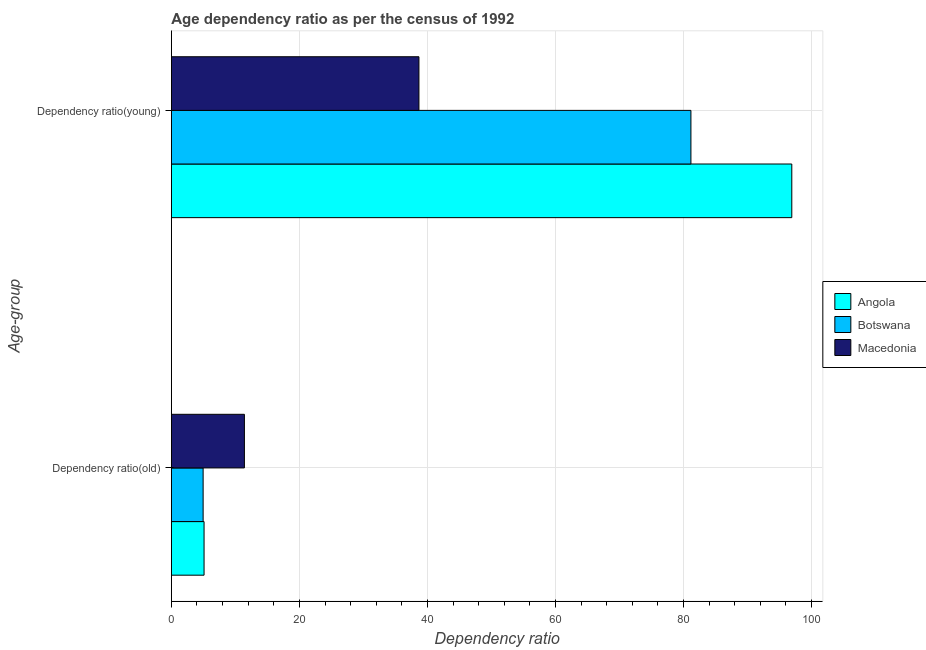How many different coloured bars are there?
Make the answer very short. 3. How many groups of bars are there?
Your answer should be compact. 2. Are the number of bars on each tick of the Y-axis equal?
Your answer should be very brief. Yes. How many bars are there on the 2nd tick from the top?
Give a very brief answer. 3. How many bars are there on the 2nd tick from the bottom?
Your response must be concise. 3. What is the label of the 2nd group of bars from the top?
Your response must be concise. Dependency ratio(old). What is the age dependency ratio(old) in Angola?
Provide a short and direct response. 5.11. Across all countries, what is the maximum age dependency ratio(old)?
Offer a very short reply. 11.41. Across all countries, what is the minimum age dependency ratio(old)?
Ensure brevity in your answer.  4.96. In which country was the age dependency ratio(young) maximum?
Give a very brief answer. Angola. In which country was the age dependency ratio(old) minimum?
Provide a short and direct response. Botswana. What is the total age dependency ratio(young) in the graph?
Your answer should be compact. 216.77. What is the difference between the age dependency ratio(old) in Macedonia and that in Angola?
Keep it short and to the point. 6.3. What is the difference between the age dependency ratio(young) in Macedonia and the age dependency ratio(old) in Botswana?
Your response must be concise. 33.72. What is the average age dependency ratio(old) per country?
Your answer should be very brief. 7.16. What is the difference between the age dependency ratio(young) and age dependency ratio(old) in Angola?
Offer a very short reply. 91.82. In how many countries, is the age dependency ratio(young) greater than 20 ?
Your answer should be compact. 3. What is the ratio of the age dependency ratio(young) in Macedonia to that in Botswana?
Make the answer very short. 0.48. In how many countries, is the age dependency ratio(young) greater than the average age dependency ratio(young) taken over all countries?
Your response must be concise. 2. What does the 1st bar from the top in Dependency ratio(old) represents?
Your answer should be compact. Macedonia. What does the 2nd bar from the bottom in Dependency ratio(old) represents?
Keep it short and to the point. Botswana. Are all the bars in the graph horizontal?
Your answer should be very brief. Yes. How many countries are there in the graph?
Your answer should be compact. 3. Does the graph contain any zero values?
Make the answer very short. No. How many legend labels are there?
Give a very brief answer. 3. What is the title of the graph?
Offer a terse response. Age dependency ratio as per the census of 1992. What is the label or title of the X-axis?
Your answer should be compact. Dependency ratio. What is the label or title of the Y-axis?
Give a very brief answer. Age-group. What is the Dependency ratio in Angola in Dependency ratio(old)?
Your response must be concise. 5.11. What is the Dependency ratio in Botswana in Dependency ratio(old)?
Ensure brevity in your answer.  4.96. What is the Dependency ratio of Macedonia in Dependency ratio(old)?
Keep it short and to the point. 11.41. What is the Dependency ratio of Angola in Dependency ratio(young)?
Your answer should be compact. 96.93. What is the Dependency ratio in Botswana in Dependency ratio(young)?
Your answer should be very brief. 81.17. What is the Dependency ratio in Macedonia in Dependency ratio(young)?
Your response must be concise. 38.68. Across all Age-group, what is the maximum Dependency ratio in Angola?
Provide a succinct answer. 96.93. Across all Age-group, what is the maximum Dependency ratio of Botswana?
Your answer should be compact. 81.17. Across all Age-group, what is the maximum Dependency ratio of Macedonia?
Give a very brief answer. 38.68. Across all Age-group, what is the minimum Dependency ratio of Angola?
Ensure brevity in your answer.  5.11. Across all Age-group, what is the minimum Dependency ratio in Botswana?
Give a very brief answer. 4.96. Across all Age-group, what is the minimum Dependency ratio in Macedonia?
Your answer should be very brief. 11.41. What is the total Dependency ratio of Angola in the graph?
Your response must be concise. 102.03. What is the total Dependency ratio in Botswana in the graph?
Ensure brevity in your answer.  86.13. What is the total Dependency ratio of Macedonia in the graph?
Keep it short and to the point. 50.09. What is the difference between the Dependency ratio of Angola in Dependency ratio(old) and that in Dependency ratio(young)?
Provide a succinct answer. -91.82. What is the difference between the Dependency ratio of Botswana in Dependency ratio(old) and that in Dependency ratio(young)?
Your answer should be compact. -76.21. What is the difference between the Dependency ratio in Macedonia in Dependency ratio(old) and that in Dependency ratio(young)?
Make the answer very short. -27.27. What is the difference between the Dependency ratio in Angola in Dependency ratio(old) and the Dependency ratio in Botswana in Dependency ratio(young)?
Your answer should be compact. -76.06. What is the difference between the Dependency ratio in Angola in Dependency ratio(old) and the Dependency ratio in Macedonia in Dependency ratio(young)?
Your answer should be compact. -33.57. What is the difference between the Dependency ratio of Botswana in Dependency ratio(old) and the Dependency ratio of Macedonia in Dependency ratio(young)?
Make the answer very short. -33.72. What is the average Dependency ratio of Angola per Age-group?
Provide a succinct answer. 51.02. What is the average Dependency ratio in Botswana per Age-group?
Give a very brief answer. 43.06. What is the average Dependency ratio in Macedonia per Age-group?
Your answer should be compact. 25.04. What is the difference between the Dependency ratio of Angola and Dependency ratio of Botswana in Dependency ratio(old)?
Your response must be concise. 0.15. What is the difference between the Dependency ratio of Angola and Dependency ratio of Macedonia in Dependency ratio(old)?
Your response must be concise. -6.3. What is the difference between the Dependency ratio of Botswana and Dependency ratio of Macedonia in Dependency ratio(old)?
Provide a short and direct response. -6.45. What is the difference between the Dependency ratio of Angola and Dependency ratio of Botswana in Dependency ratio(young)?
Keep it short and to the point. 15.76. What is the difference between the Dependency ratio of Angola and Dependency ratio of Macedonia in Dependency ratio(young)?
Your answer should be compact. 58.25. What is the difference between the Dependency ratio in Botswana and Dependency ratio in Macedonia in Dependency ratio(young)?
Provide a short and direct response. 42.49. What is the ratio of the Dependency ratio in Angola in Dependency ratio(old) to that in Dependency ratio(young)?
Offer a very short reply. 0.05. What is the ratio of the Dependency ratio of Botswana in Dependency ratio(old) to that in Dependency ratio(young)?
Your answer should be compact. 0.06. What is the ratio of the Dependency ratio of Macedonia in Dependency ratio(old) to that in Dependency ratio(young)?
Provide a short and direct response. 0.29. What is the difference between the highest and the second highest Dependency ratio in Angola?
Give a very brief answer. 91.82. What is the difference between the highest and the second highest Dependency ratio in Botswana?
Keep it short and to the point. 76.21. What is the difference between the highest and the second highest Dependency ratio of Macedonia?
Keep it short and to the point. 27.27. What is the difference between the highest and the lowest Dependency ratio in Angola?
Your answer should be compact. 91.82. What is the difference between the highest and the lowest Dependency ratio in Botswana?
Keep it short and to the point. 76.21. What is the difference between the highest and the lowest Dependency ratio in Macedonia?
Make the answer very short. 27.27. 